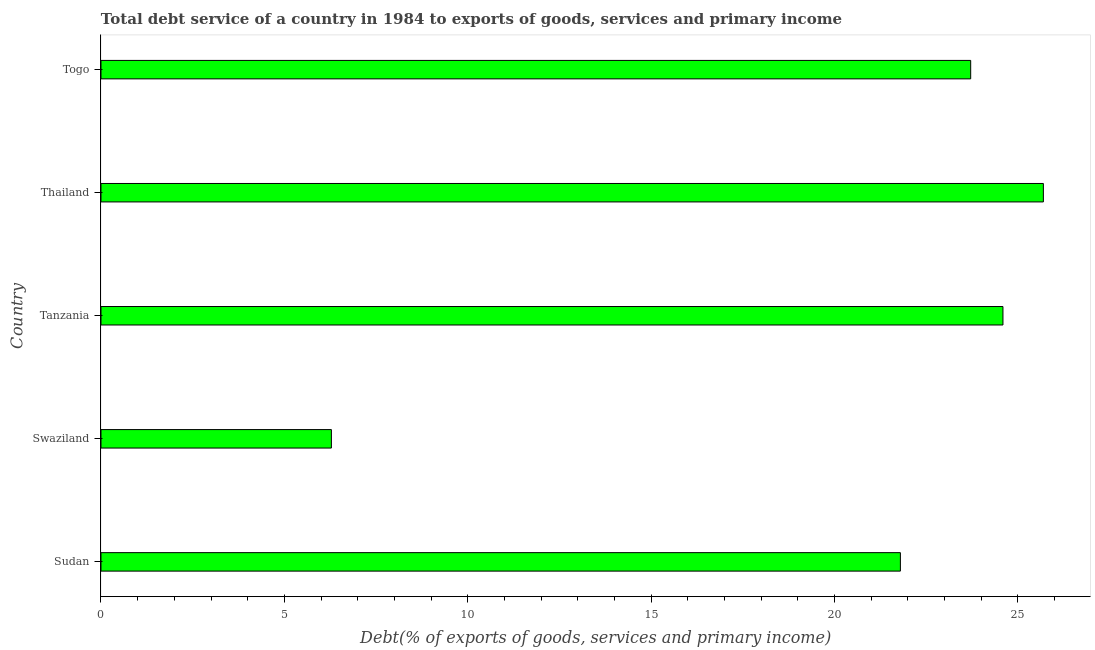What is the title of the graph?
Offer a very short reply. Total debt service of a country in 1984 to exports of goods, services and primary income. What is the label or title of the X-axis?
Provide a succinct answer. Debt(% of exports of goods, services and primary income). What is the label or title of the Y-axis?
Make the answer very short. Country. What is the total debt service in Sudan?
Ensure brevity in your answer.  21.8. Across all countries, what is the maximum total debt service?
Your answer should be very brief. 25.7. Across all countries, what is the minimum total debt service?
Keep it short and to the point. 6.28. In which country was the total debt service maximum?
Offer a very short reply. Thailand. In which country was the total debt service minimum?
Give a very brief answer. Swaziland. What is the sum of the total debt service?
Give a very brief answer. 102.08. What is the difference between the total debt service in Sudan and Togo?
Ensure brevity in your answer.  -1.92. What is the average total debt service per country?
Give a very brief answer. 20.42. What is the median total debt service?
Make the answer very short. 23.71. In how many countries, is the total debt service greater than 13 %?
Your response must be concise. 4. What is the ratio of the total debt service in Swaziland to that in Thailand?
Provide a succinct answer. 0.24. Is the difference between the total debt service in Sudan and Togo greater than the difference between any two countries?
Ensure brevity in your answer.  No. What is the difference between the highest and the second highest total debt service?
Give a very brief answer. 1.1. Is the sum of the total debt service in Tanzania and Thailand greater than the maximum total debt service across all countries?
Keep it short and to the point. Yes. What is the difference between the highest and the lowest total debt service?
Your answer should be compact. 19.41. In how many countries, is the total debt service greater than the average total debt service taken over all countries?
Your response must be concise. 4. What is the difference between two consecutive major ticks on the X-axis?
Keep it short and to the point. 5. Are the values on the major ticks of X-axis written in scientific E-notation?
Ensure brevity in your answer.  No. What is the Debt(% of exports of goods, services and primary income) of Sudan?
Offer a terse response. 21.8. What is the Debt(% of exports of goods, services and primary income) in Swaziland?
Your answer should be very brief. 6.28. What is the Debt(% of exports of goods, services and primary income) in Tanzania?
Your answer should be very brief. 24.59. What is the Debt(% of exports of goods, services and primary income) in Thailand?
Keep it short and to the point. 25.7. What is the Debt(% of exports of goods, services and primary income) of Togo?
Make the answer very short. 23.71. What is the difference between the Debt(% of exports of goods, services and primary income) in Sudan and Swaziland?
Your answer should be compact. 15.51. What is the difference between the Debt(% of exports of goods, services and primary income) in Sudan and Tanzania?
Provide a short and direct response. -2.8. What is the difference between the Debt(% of exports of goods, services and primary income) in Sudan and Thailand?
Keep it short and to the point. -3.9. What is the difference between the Debt(% of exports of goods, services and primary income) in Sudan and Togo?
Your response must be concise. -1.92. What is the difference between the Debt(% of exports of goods, services and primary income) in Swaziland and Tanzania?
Keep it short and to the point. -18.31. What is the difference between the Debt(% of exports of goods, services and primary income) in Swaziland and Thailand?
Provide a succinct answer. -19.41. What is the difference between the Debt(% of exports of goods, services and primary income) in Swaziland and Togo?
Offer a terse response. -17.43. What is the difference between the Debt(% of exports of goods, services and primary income) in Tanzania and Thailand?
Make the answer very short. -1.1. What is the difference between the Debt(% of exports of goods, services and primary income) in Tanzania and Togo?
Make the answer very short. 0.88. What is the difference between the Debt(% of exports of goods, services and primary income) in Thailand and Togo?
Ensure brevity in your answer.  1.98. What is the ratio of the Debt(% of exports of goods, services and primary income) in Sudan to that in Swaziland?
Your answer should be very brief. 3.47. What is the ratio of the Debt(% of exports of goods, services and primary income) in Sudan to that in Tanzania?
Ensure brevity in your answer.  0.89. What is the ratio of the Debt(% of exports of goods, services and primary income) in Sudan to that in Thailand?
Ensure brevity in your answer.  0.85. What is the ratio of the Debt(% of exports of goods, services and primary income) in Sudan to that in Togo?
Provide a succinct answer. 0.92. What is the ratio of the Debt(% of exports of goods, services and primary income) in Swaziland to that in Tanzania?
Keep it short and to the point. 0.26. What is the ratio of the Debt(% of exports of goods, services and primary income) in Swaziland to that in Thailand?
Ensure brevity in your answer.  0.24. What is the ratio of the Debt(% of exports of goods, services and primary income) in Swaziland to that in Togo?
Provide a short and direct response. 0.27. What is the ratio of the Debt(% of exports of goods, services and primary income) in Tanzania to that in Thailand?
Provide a short and direct response. 0.96. What is the ratio of the Debt(% of exports of goods, services and primary income) in Tanzania to that in Togo?
Make the answer very short. 1.04. What is the ratio of the Debt(% of exports of goods, services and primary income) in Thailand to that in Togo?
Make the answer very short. 1.08. 